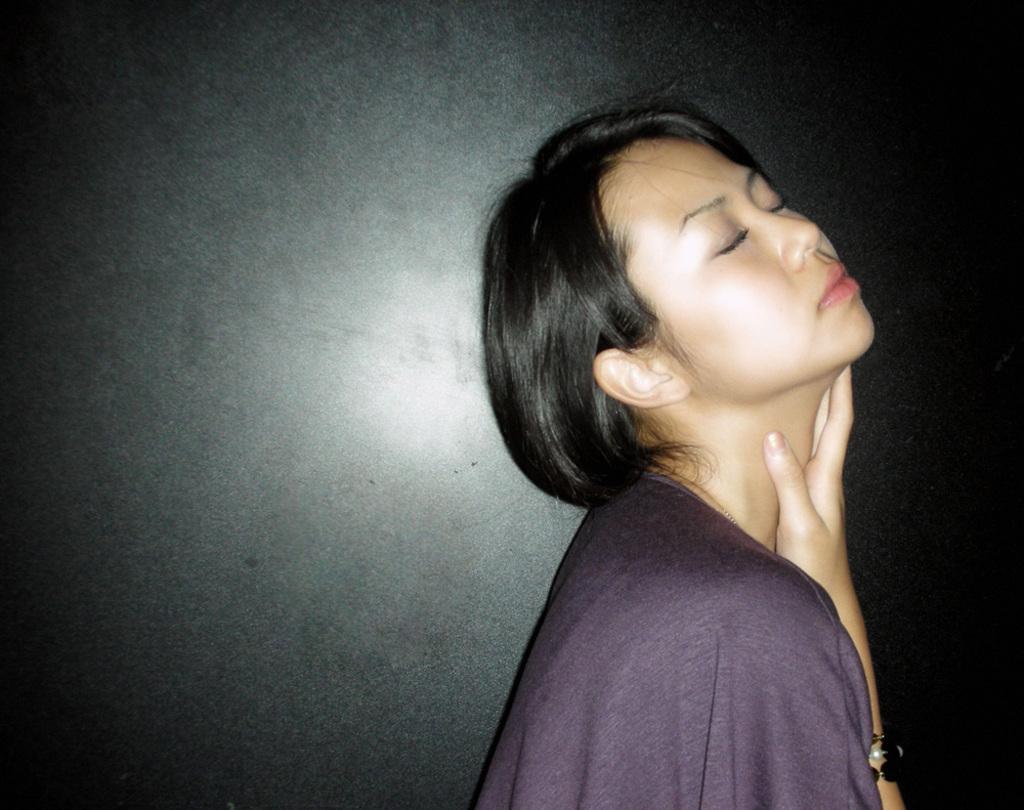Could you give a brief overview of what you see in this image? In this image we can see a person. In the background of the image there is a wall. 